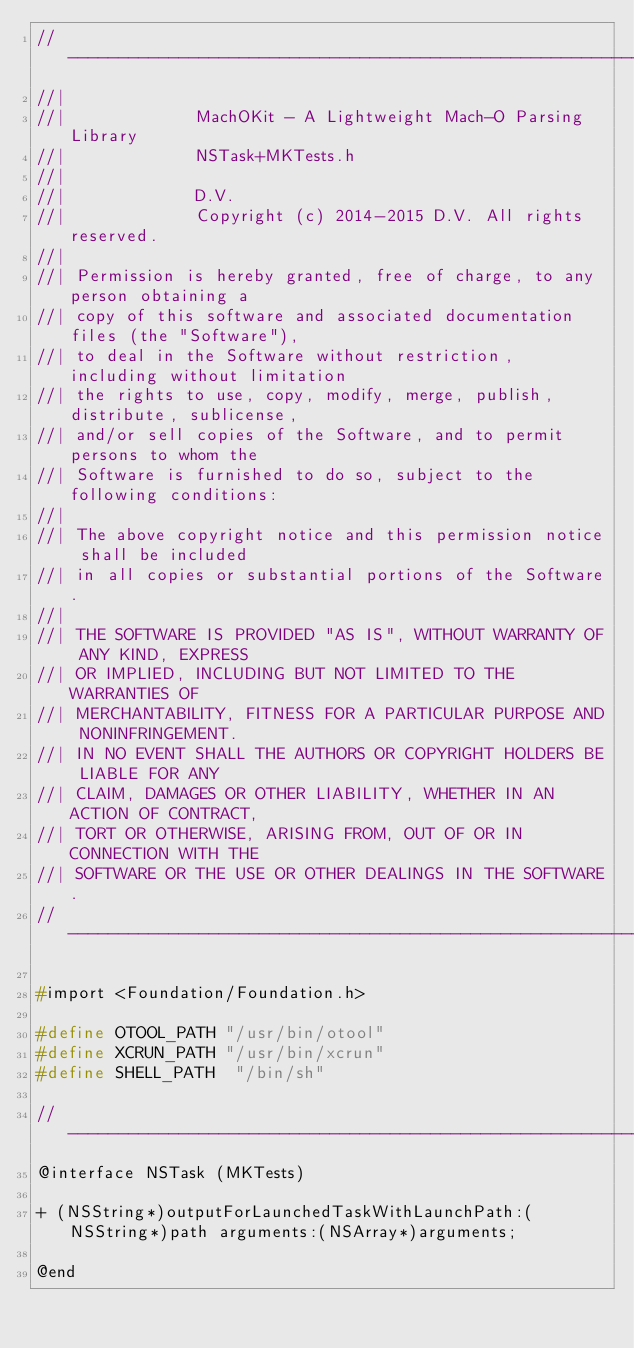Convert code to text. <code><loc_0><loc_0><loc_500><loc_500><_C_>//----------------------------------------------------------------------------//
//|
//|             MachOKit - A Lightweight Mach-O Parsing Library
//|             NSTask+MKTests.h
//|
//|             D.V.
//|             Copyright (c) 2014-2015 D.V. All rights reserved.
//|
//| Permission is hereby granted, free of charge, to any person obtaining a
//| copy of this software and associated documentation files (the "Software"),
//| to deal in the Software without restriction, including without limitation
//| the rights to use, copy, modify, merge, publish, distribute, sublicense,
//| and/or sell copies of the Software, and to permit persons to whom the
//| Software is furnished to do so, subject to the following conditions:
//|
//| The above copyright notice and this permission notice shall be included
//| in all copies or substantial portions of the Software.
//|
//| THE SOFTWARE IS PROVIDED "AS IS", WITHOUT WARRANTY OF ANY KIND, EXPRESS
//| OR IMPLIED, INCLUDING BUT NOT LIMITED TO THE WARRANTIES OF
//| MERCHANTABILITY, FITNESS FOR A PARTICULAR PURPOSE AND NONINFRINGEMENT.
//| IN NO EVENT SHALL THE AUTHORS OR COPYRIGHT HOLDERS BE LIABLE FOR ANY
//| CLAIM, DAMAGES OR OTHER LIABILITY, WHETHER IN AN ACTION OF CONTRACT,
//| TORT OR OTHERWISE, ARISING FROM, OUT OF OR IN CONNECTION WITH THE
//| SOFTWARE OR THE USE OR OTHER DEALINGS IN THE SOFTWARE.
//----------------------------------------------------------------------------//

#import <Foundation/Foundation.h>

#define OTOOL_PATH "/usr/bin/otool"
#define XCRUN_PATH "/usr/bin/xcrun"
#define SHELL_PATH  "/bin/sh"

//----------------------------------------------------------------------------//
@interface NSTask (MKTests)

+ (NSString*)outputForLaunchedTaskWithLaunchPath:(NSString*)path arguments:(NSArray*)arguments;

@end
</code> 